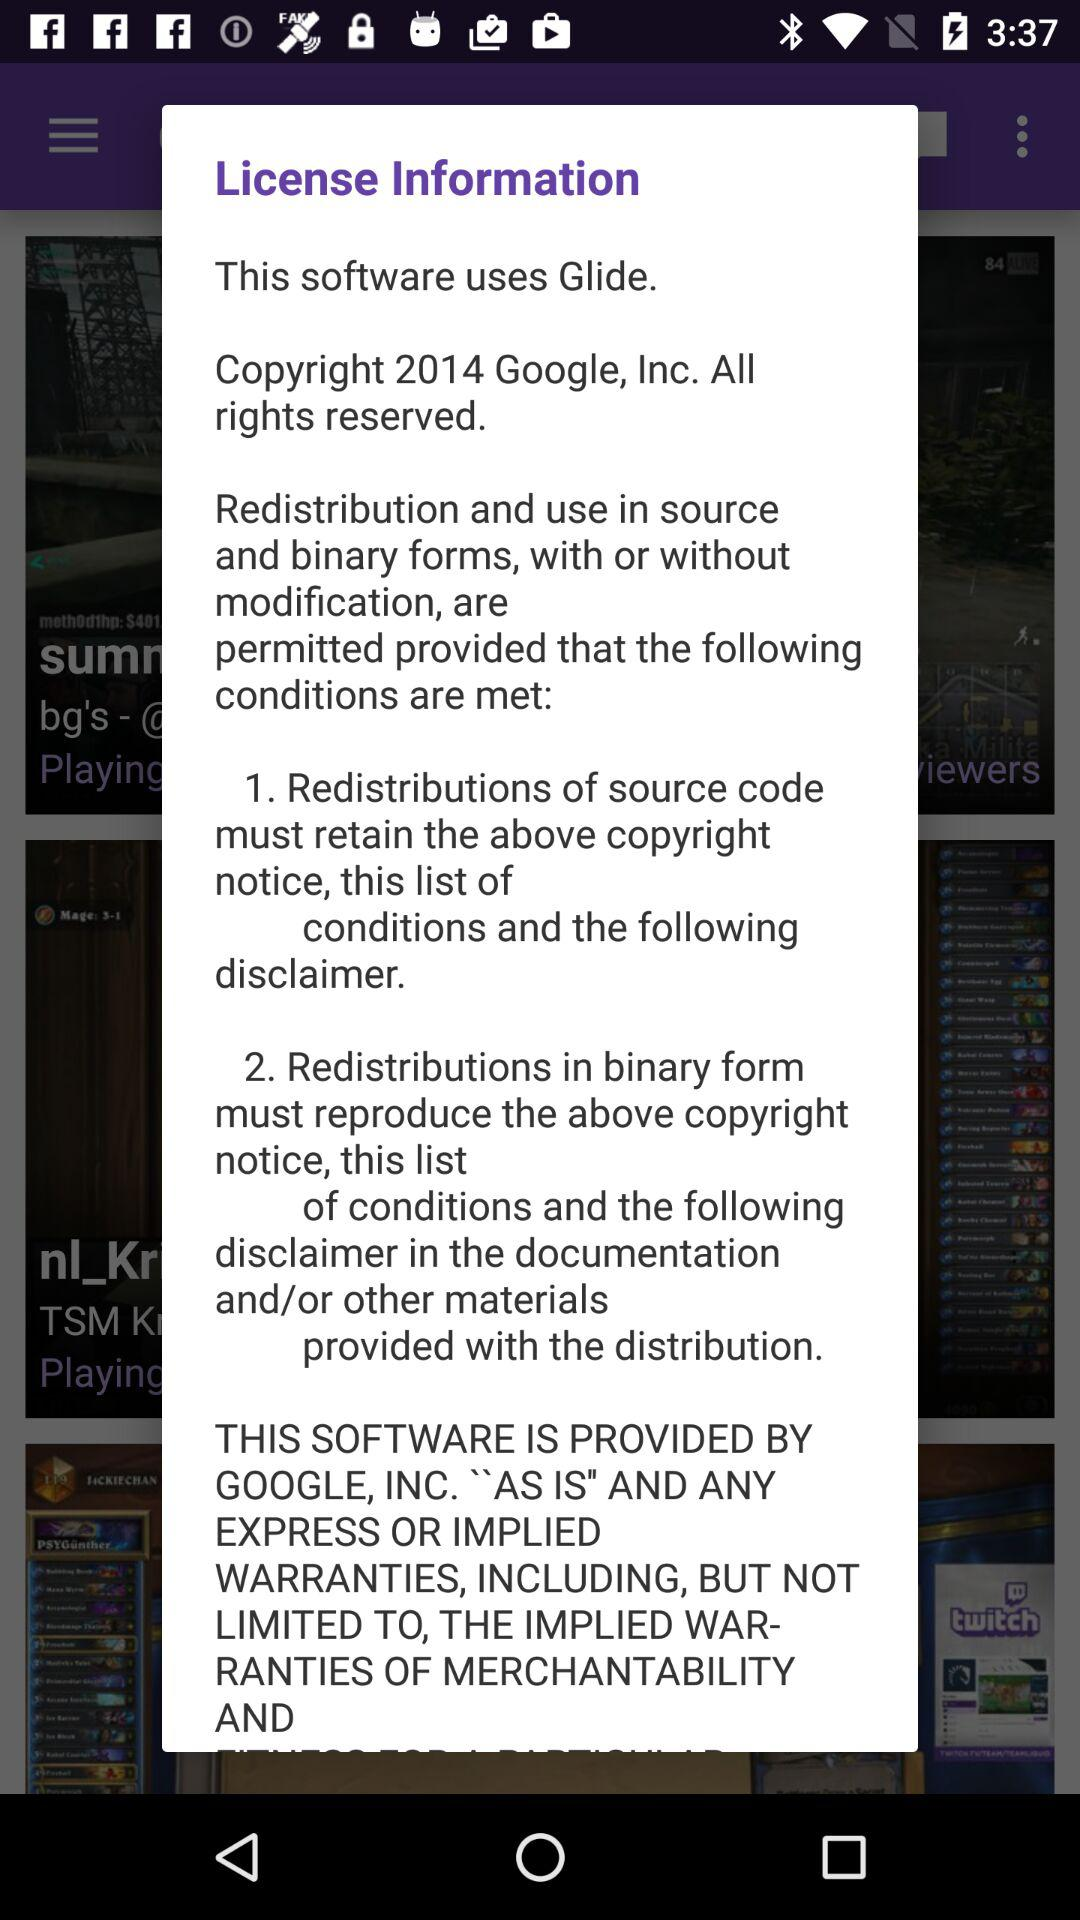How many copyright notices are there in the license information?
Answer the question using a single word or phrase. 2 